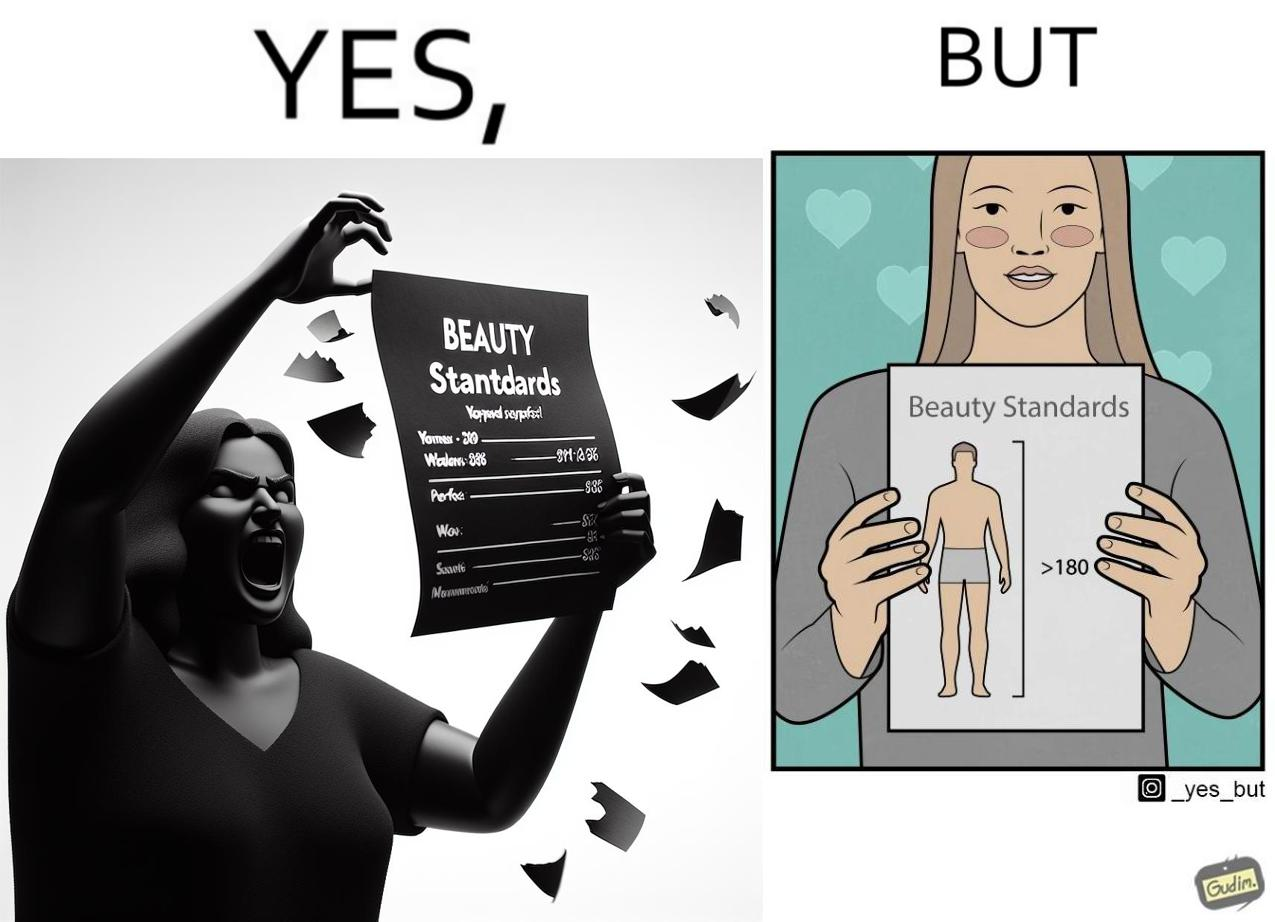Provide a description of this image. The image is ironic because the woman that is angry about having constraints set on the body parts of a woman to be considered beautiful is the same person who is happily presenting contraints on the height of a man to be considered beautiful. 